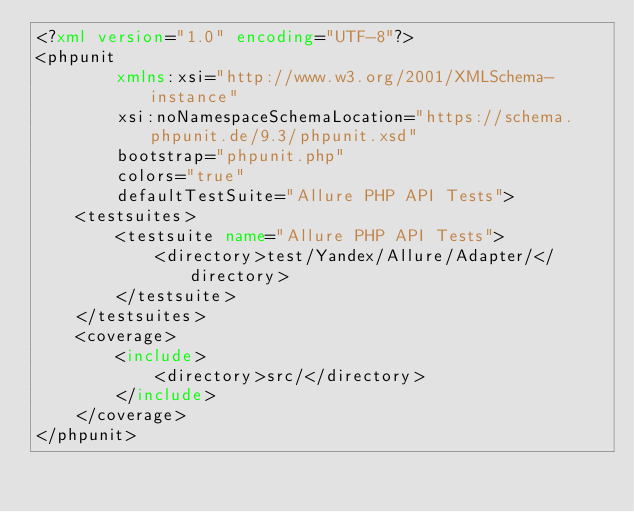<code> <loc_0><loc_0><loc_500><loc_500><_XML_><?xml version="1.0" encoding="UTF-8"?>
<phpunit
        xmlns:xsi="http://www.w3.org/2001/XMLSchema-instance"
        xsi:noNamespaceSchemaLocation="https://schema.phpunit.de/9.3/phpunit.xsd"
        bootstrap="phpunit.php"
        colors="true"
        defaultTestSuite="Allure PHP API Tests">
    <testsuites>
        <testsuite name="Allure PHP API Tests">
            <directory>test/Yandex/Allure/Adapter/</directory>
        </testsuite>
    </testsuites>
    <coverage>
        <include>
            <directory>src/</directory>
        </include>
    </coverage>
</phpunit></code> 